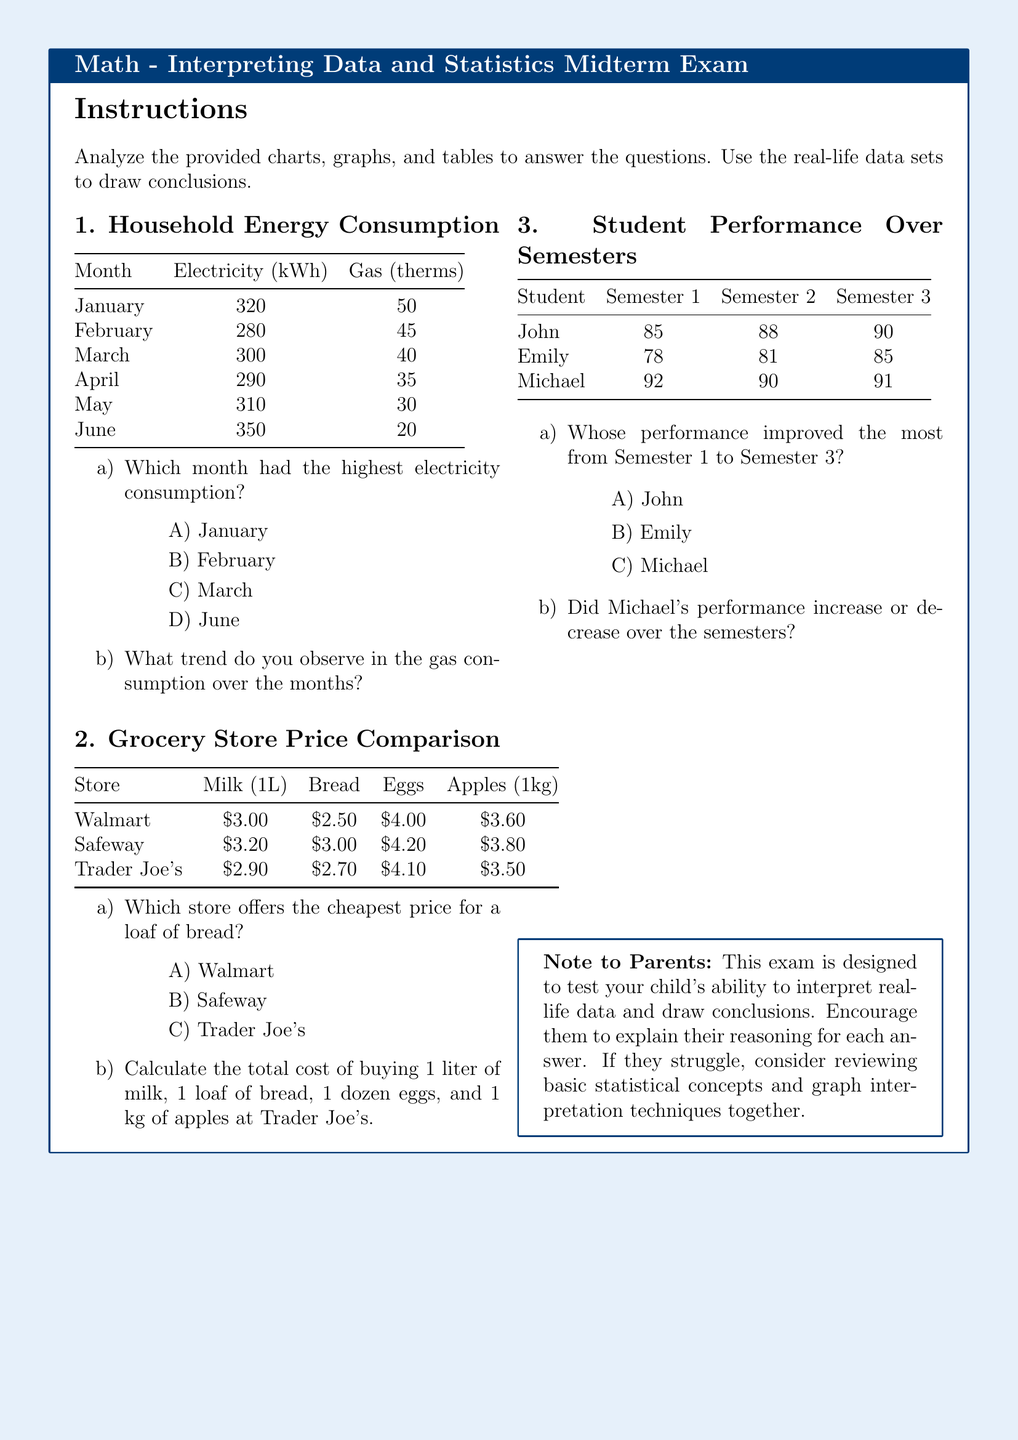What month had the highest electricity consumption? The highest electricity consumption was recorded in January with 320 kWh.
Answer: January What is the gas consumption in March? The gas consumption in March is 40 therms.
Answer: 40 Which store has the highest price for milk? The store with the highest price for milk is Safeway at $3.20.
Answer: Safeway What is the total cost of items at Trader Joe's? The total cost is calculated as $2.90 (milk) + $2.70 (bread) + $4.10 (eggs, assuming 1 dozen = 12 eggs) + $3.50 (apples) which equals $13.20.
Answer: $13.20 Who had the lowest performance in Semester 2? Emily had the lowest performance in Semester 2 with a score of 81.
Answer: Emily What was the improvement in John's performance from Semester 1 to Semester 3? John improved from 85 in Semester 1 to 90 in Semester 3, which is an increase of 5 points.
Answer: 5 Did Michael's performance increase or decrease over the semesters? Michael's performance increased as he scored 92, 90, and 91 in the three semesters.
Answer: Increase Which store offers the cheapest price for apples? The cheapest price for apples is found at Trader Joe's, priced at $3.50.
Answer: Trader Joe's What was the gas consumption in June? The gas consumption in June is 20 therms.
Answer: 20 Which student had the highest performance in Semester 1? Michael had the highest performance in Semester 1 with a score of 92.
Answer: Michael 